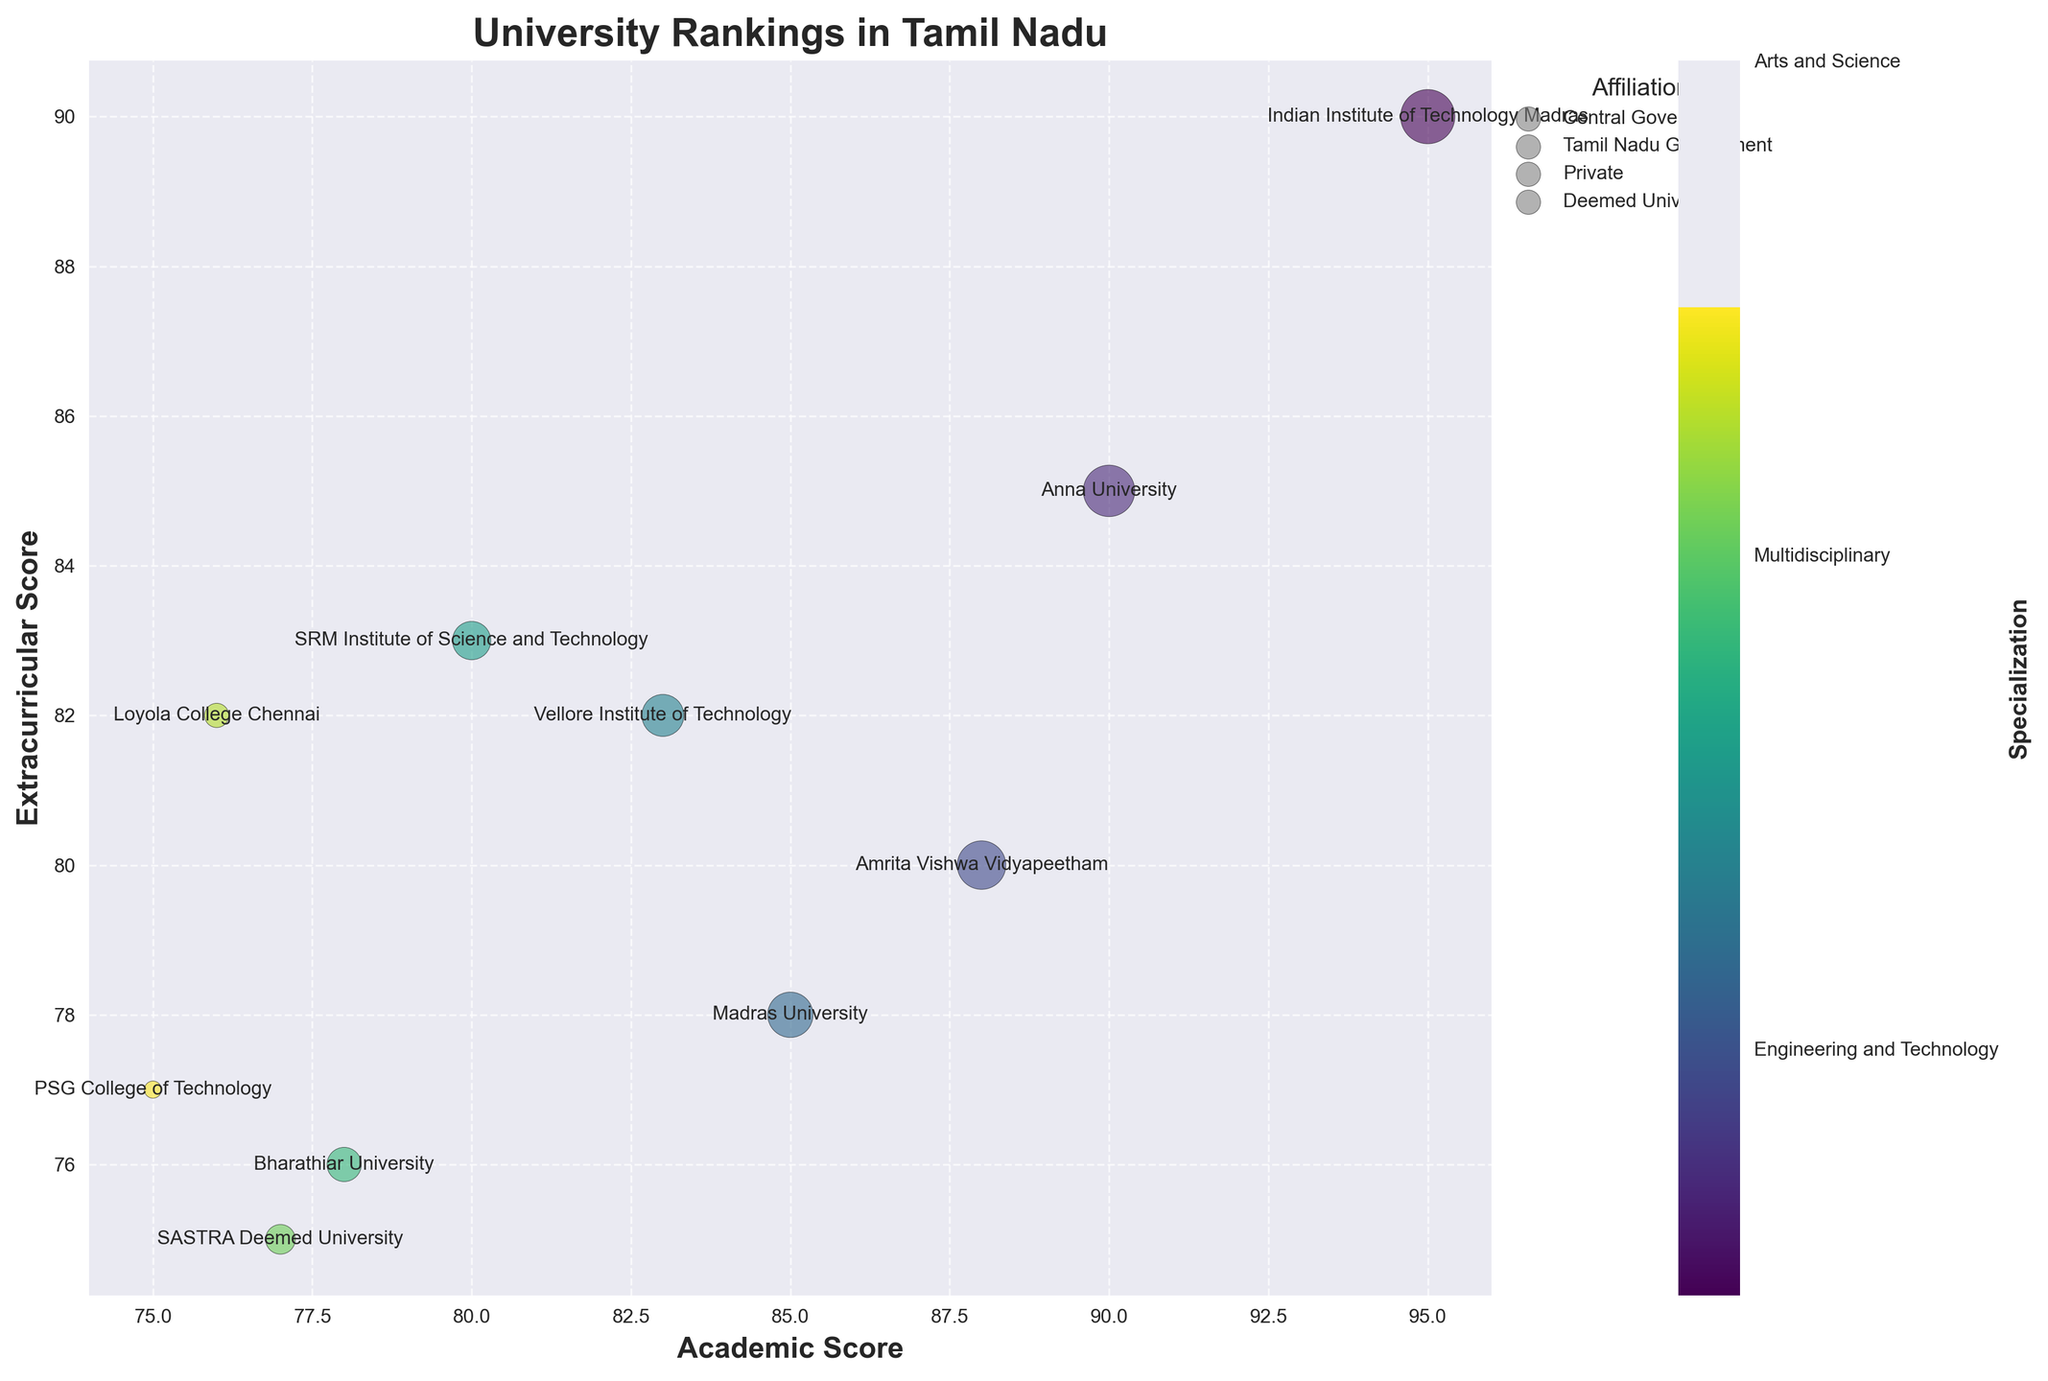What is the title of the figure? The title of the figure is usually placed at the top. By looking at the top part of the chart, we can see the title.
Answer: University Rankings in Tamil Nadu Which university has the highest academic score? The highest value on the x-axis represents the highest academic score. The bubble closest to the right end of the x-axis represents this university.
Answer: Indian Institute of Technology Madras What is the academic score of Vellore Institute of Technology? Locate the bubble labeled 'Vellore Institute of Technology'. The corresponding x-axis value of this bubble represents its academic score.
Answer: 83 How many universities have an extracurricular score above 80? Identify the bubbles that lie above the y-axis value of 80. Count the number of such bubbles.
Answer: 5 Which university has the largest bubble on the chart? Bubble size is inversely proportional to the ranking. The largest bubble corresponds to the highest ranking university.
Answer: Indian Institute of Technology Madras Which universities have an affiliation with the Tamil Nadu Government? Look at the legend's section titled 'Affiliation' and identify the symbol/color for 'Tamil Nadu Government'. Locate the bubbles in the chart with this symbol/color.
Answer: Anna University, Madras University, Bharathiar University What is the average extracurricular score of all universities ranked between 3 and 7? Locate the universities ranked 3 to 7. Sum their extracurricular scores and divide the total by the number of these universities for the average. (80 + 78 + 82 + 83 + 76)/5
Answer: 79.8 Which university specializing in Arts and Science has the highest academic score? Identify the bubbles with the specialization 'Arts and Science' from the color bar. Among these, find the bubble with the highest x-axis value.
Answer: Madras University How do the extracurricular scores of private universities compare to those of Tamil Nadu Government universities? Identify bubbles with 'Private' and 'Tamil Nadu Government' affiliations using the legend. Compare their y-axis values (extracurricular scores).
Answer: Private universities tend to have slightly higher extracurricular scores Which universities are multidisciplinary and what are their rankings? Use the color bar to locate bubbles with the specialization 'Multidisciplinary'. Note the ranks of these bubbles.
Answer: Amrita Vishwa Vidyapeetham (Rank 3) 